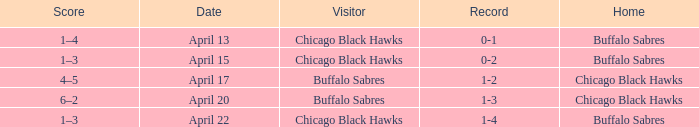When has a Record of 1-3? April 20. 